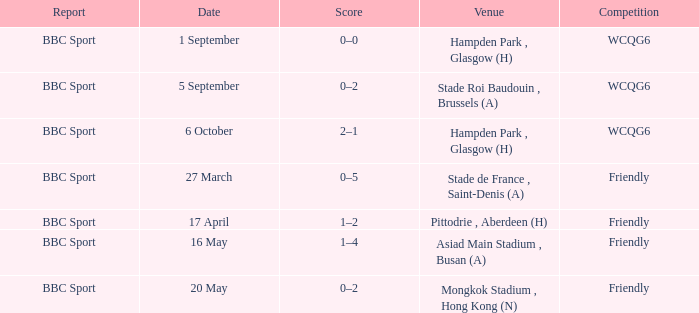What was the score of the game on 1 september? 0–0. 